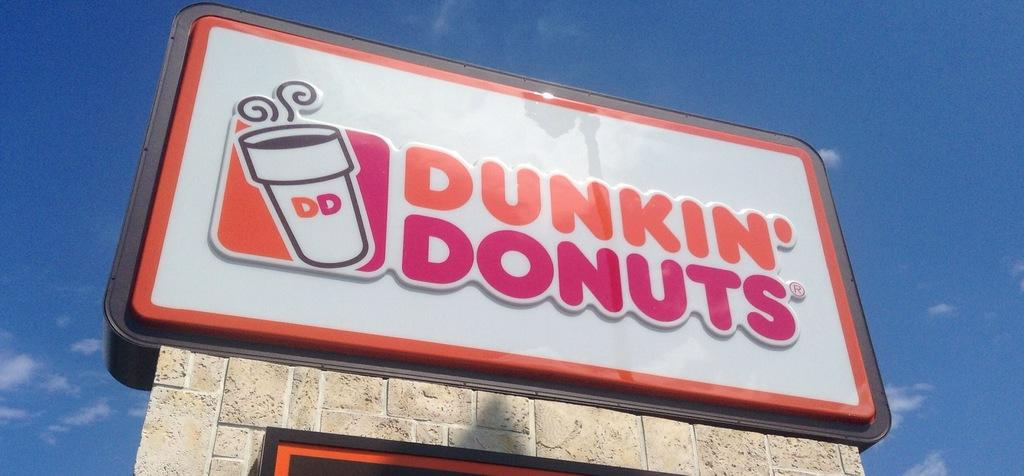Provide a one-sentence caption for the provided image. Dunkin' Donuts large sign outside their store location. 